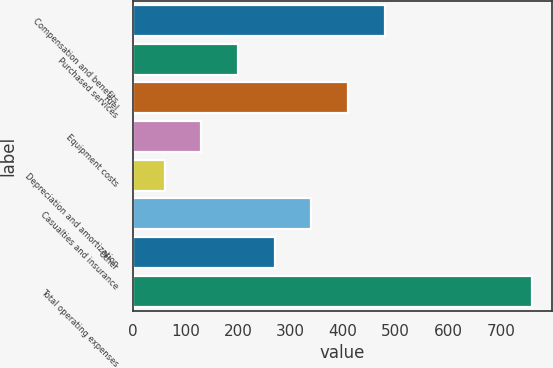Convert chart. <chart><loc_0><loc_0><loc_500><loc_500><bar_chart><fcel>Compensation and benefits<fcel>Purchased services<fcel>Fuel<fcel>Equipment costs<fcel>Depreciation and amortization<fcel>Casualties and insurance<fcel>Other<fcel>Total operating expenses<nl><fcel>479.58<fcel>199.86<fcel>409.65<fcel>129.93<fcel>60<fcel>339.72<fcel>269.79<fcel>759.3<nl></chart> 